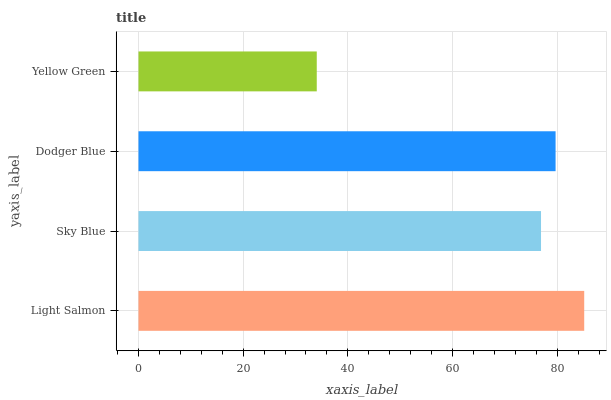Is Yellow Green the minimum?
Answer yes or no. Yes. Is Light Salmon the maximum?
Answer yes or no. Yes. Is Sky Blue the minimum?
Answer yes or no. No. Is Sky Blue the maximum?
Answer yes or no. No. Is Light Salmon greater than Sky Blue?
Answer yes or no. Yes. Is Sky Blue less than Light Salmon?
Answer yes or no. Yes. Is Sky Blue greater than Light Salmon?
Answer yes or no. No. Is Light Salmon less than Sky Blue?
Answer yes or no. No. Is Dodger Blue the high median?
Answer yes or no. Yes. Is Sky Blue the low median?
Answer yes or no. Yes. Is Sky Blue the high median?
Answer yes or no. No. Is Light Salmon the low median?
Answer yes or no. No. 